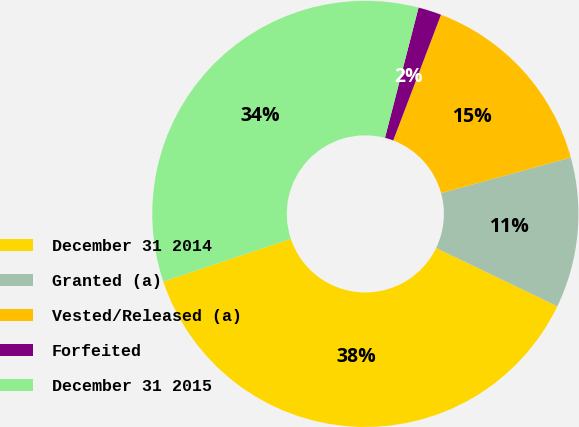Convert chart. <chart><loc_0><loc_0><loc_500><loc_500><pie_chart><fcel>December 31 2014<fcel>Granted (a)<fcel>Vested/Released (a)<fcel>Forfeited<fcel>December 31 2015<nl><fcel>37.72%<fcel>11.4%<fcel>14.96%<fcel>1.76%<fcel>34.16%<nl></chart> 